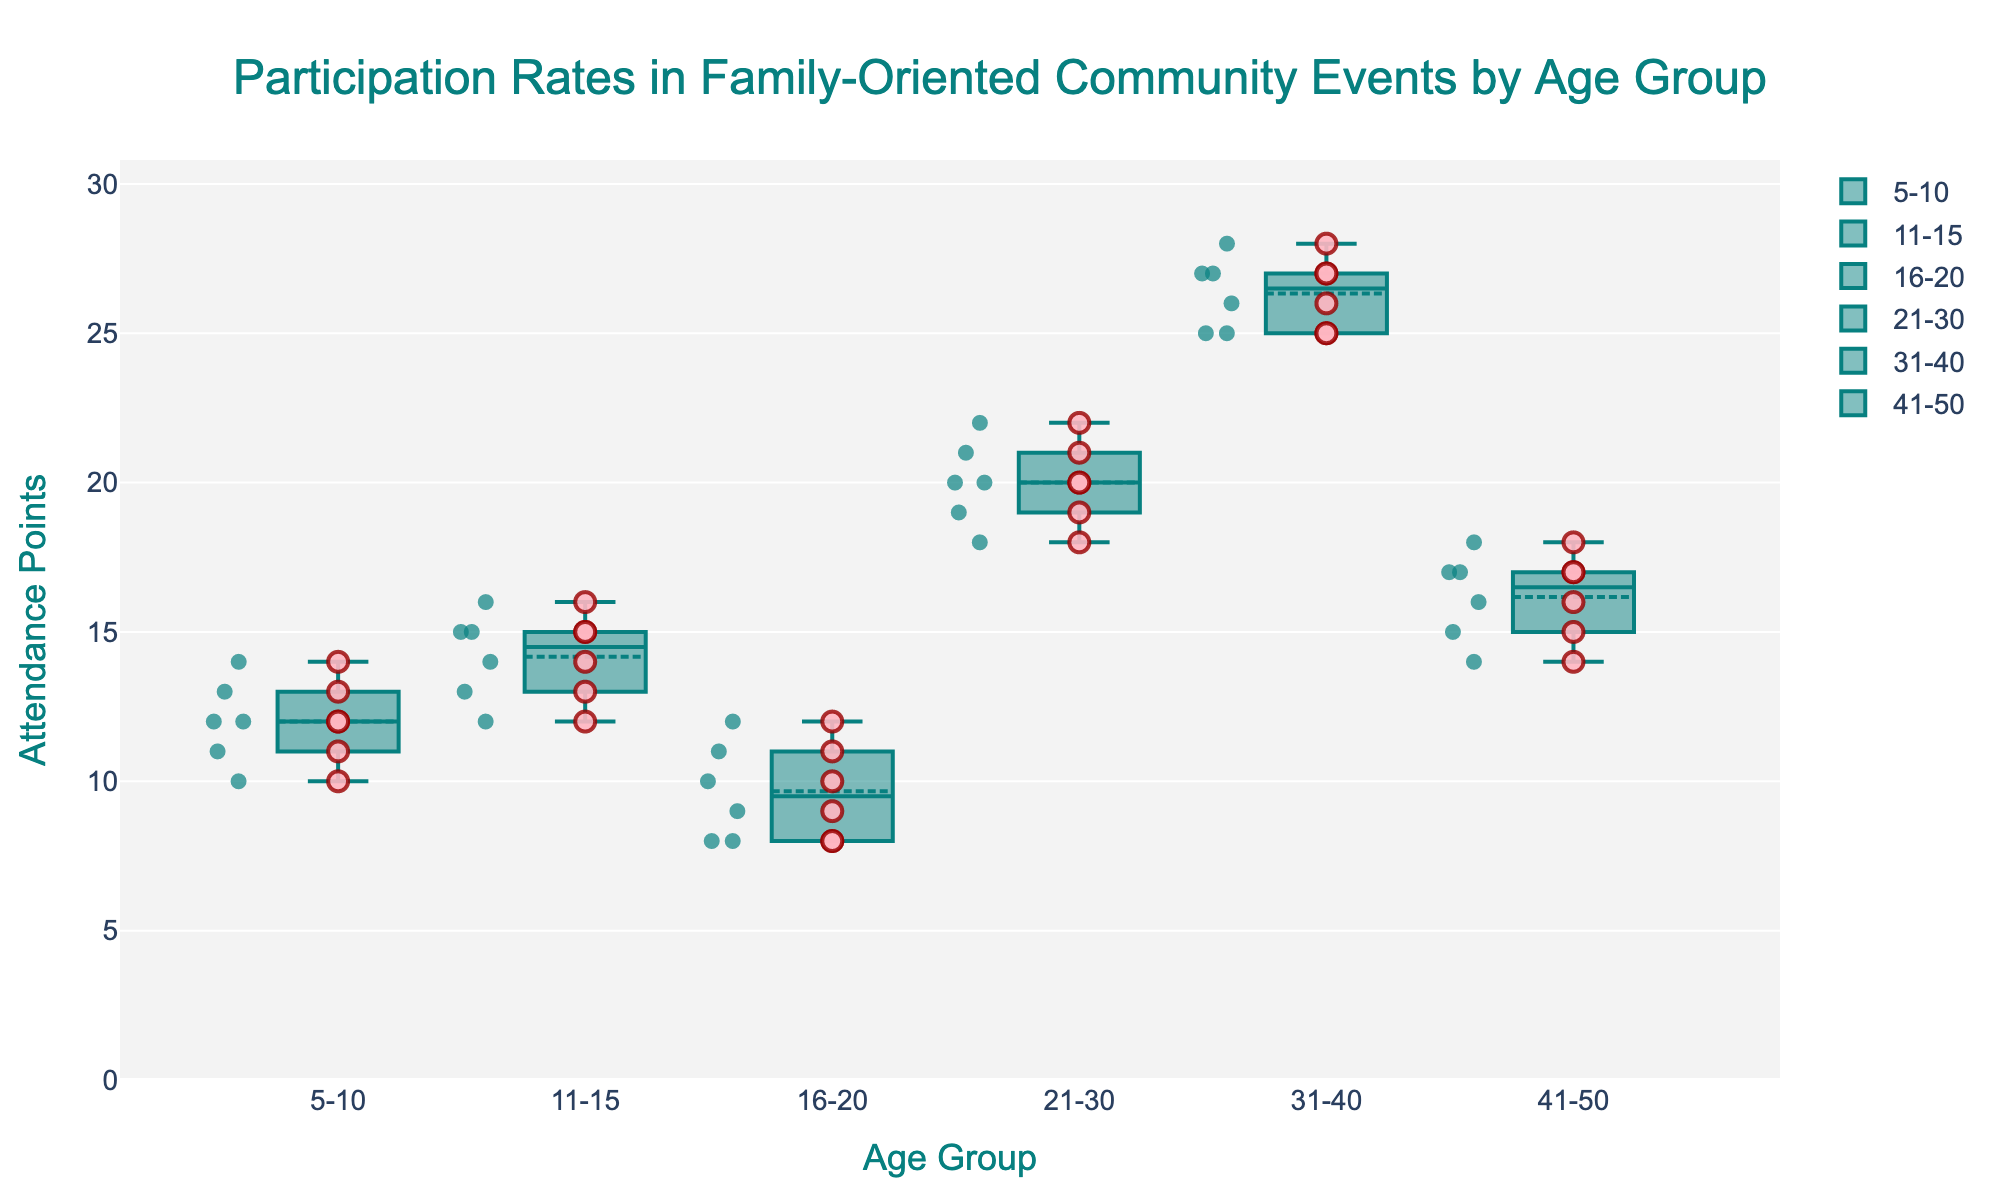What is the title of the plot? The title of the plot is usually displayed at the top center and is designed to give a summary of what the visualization is about. It says "Participation Rates in Family-Oriented Community Events by Age Group."
Answer: Participation Rates in Family-Oriented Community Events by Age Group How many age groups are represented in the figure? By examining the x-axis labels, we can see different categories representing age groups. There are six distinct age groups shown.
Answer: Six Which age group has the highest median attendance points? By looking at the middle line inside each box (representing the median), we can compare all the age groups. The 31-40 age group has the highest median around 26.
Answer: 31-40 What is the interquartile range (IQR) for the 21-30 age group? The IQR is calculated as the difference between the third quartile (Q3) and the first quartile (Q1). For the 21-30 age group, Q3 appears around 21 and Q1 around 19, so the IQR is 21 - 19 = 2.
Answer: 2 Which age group displays the widest range in attendance points? The widest range in attendance points can be determined by comparing the distance between the lowest and highest points for each age group in the box plot. The 5-10 age group shows the widest range, from 10 to 14.
Answer: 5-10 How does the median attendance for the 5-10 age group compare to the median attendance for the 41-50 age group? The median is the center line inside the box for each age group. The 5-10 age group has a median of around 12, while the 41-50 age group has a median of around 16. Therefore, the median attendance for the 41-50 age group is higher.
Answer: The 41-50 age group is higher Are there any age groups with outliers in their attendance data? Outliers are usually marked by individual points far outside the whiskers of the box plot. In this figure, there are no distinct outliers clearly far from the whiskers for any age group.
Answer: No Which age group has the most compact attendance distribution, and how can you tell? The most compact distribution can be identified by looking at the length of the box and whiskers. The 21-30 age group has the most compact distribution, with a narrow interquartile range and whiskers close together.
Answer: 21-30 What is the difference in the highest attendance point between the 11-15 age group and the 5-10 age group? The highest attendance points are the top part of the whiskers. For the 11-15 age group, it is 16, and for the 5-10 age group, it is 14. The difference is 16 - 14 = 2.
Answer: 2 